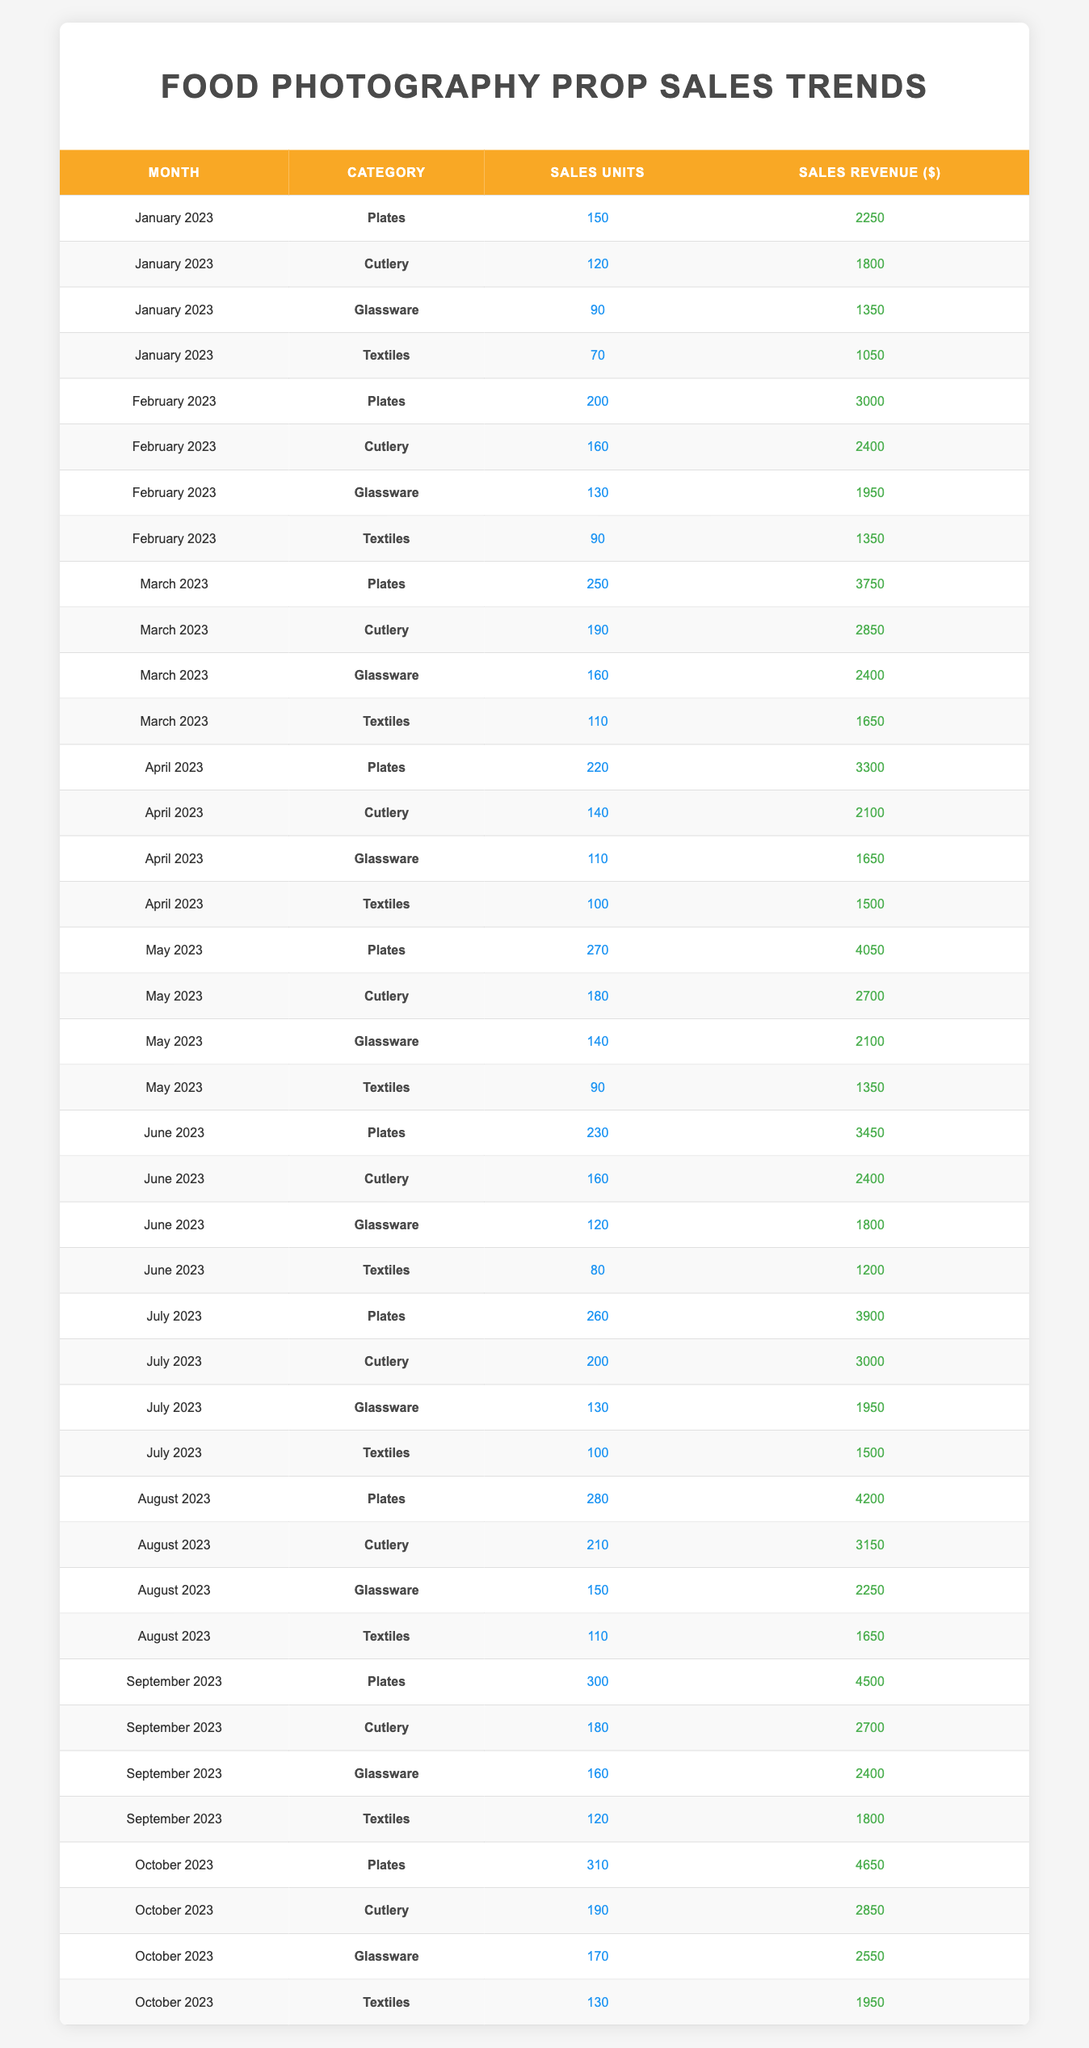What is the total sales revenue for Glassware in January 2023? In January 2023, the sales revenue for Glassware is listed as $1350. There are no additional calculations needed since there is only one data point for Glassware in that month.
Answer: $1350 Which category had the highest sales units in March 2023? In March 2023, the sales units for each category are: Plates (250), Cutlery (190), Glassware (160), and Textiles (110). The highest value is for Plates with 250 units sold.
Answer: Plates What is the average sales revenue for Textiles over the first four months of 2023? The sales revenues for Textiles in the first four months are: January ($1050), February ($1350), March ($1650), and April ($1500). The average is calculated by summing these values (1050 + 1350 + 1650 + 1500 = 4550) and dividing by 4, resulting in 4550 / 4 = 1137.5.
Answer: $1137.50 Did the sales units for Cutlery increase or decrease from July to August 2023? In July 2023, the sales units for Cutlery were 200, and in August 2023, they were 210. Since 210 is greater than 200, it indicates an increase.
Answer: Increase What is the total number of sales units for Plates from January to October 2023? To find the total sales units for Plates, add the units for each month: January (150) + February (200) + March (250) + April (220) + May (270) + June (230) + July (260) + August (280) + September (300) + October (310) = 2170.
Answer: 2170 What is the difference in sales revenue for Glassware between September and October 2023? In September 2023, Glassware had a sales revenue of $2400, and in October 2023, it was $2550. The difference is calculated as $2550 - $2400 = $150.
Answer: $150 Which month recorded the highest sales revenue for Cutlery? The recorded revenues for Cutlery in each month are: January ($1800), February ($2400), March ($2850), April ($2100), May ($2700), June ($2400), July ($3000), August ($3150), September ($2700), and October ($2850). The highest value is in August 2023 at $3150.
Answer: August 2023 How much total revenue did Textiles generate from January to June 2023, and what is the average monthly revenue for this category during this period? Textiles generated revenues of $1050 (January) + $1350 (February) + $1650 (March) + $1500 (April) + $1350 (May) + $1200 (June) = $10500. To find the monthly average, divide by 6, which gives $10500 / 6 = $1750.
Answer: Total: $10500, Average: $1750 Was the sales revenue for Glassware higher or lower in April 2023 compared to May 2023? The sales revenue for Glassware in April 2023 is $1650, and in May 2023 it is $2100. Since $2100 is greater than $1650, the revenue in May is higher.
Answer: Higher 